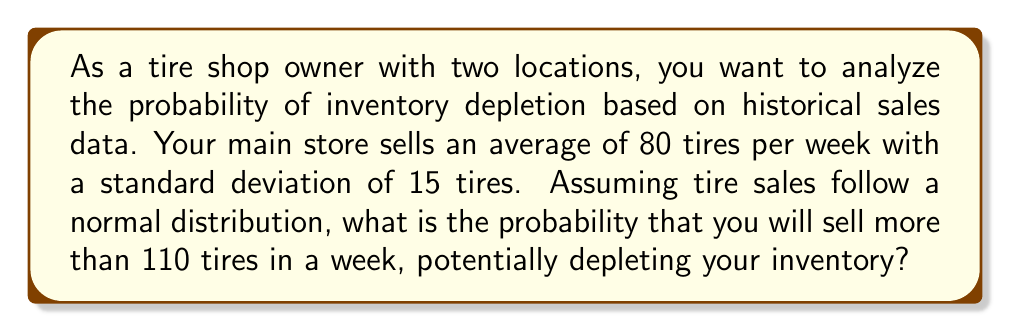Provide a solution to this math problem. To solve this problem, we'll use the properties of the normal distribution and the concept of z-scores.

Given:
- Mean (μ) = 80 tires per week
- Standard deviation (σ) = 15 tires
- We want to find P(X > 110), where X is the number of tires sold in a week

Steps:
1. Calculate the z-score for 110 tires:
   $$ z = \frac{x - \mu}{\sigma} = \frac{110 - 80}{15} = 2 $$

2. The z-score of 2 represents the number of standard deviations above the mean.

3. To find the probability, we need to find the area under the standard normal curve to the right of z = 2.

4. Using a standard normal table or calculator, we can find that:
   $$ P(Z > 2) \approx 0.0228 $$

5. Therefore, the probability of selling more than 110 tires in a week is approximately 0.0228 or 2.28%.

This means that there's a relatively small chance of depleting your inventory in a given week if your stock is based on the average sales plus two standard deviations (110 tires). However, it's still important to monitor inventory levels and perhaps consider keeping a safety stock to avoid stockouts.
Answer: The probability of selling more than 110 tires in a week, potentially depleting inventory, is approximately 0.0228 or 2.28%. 